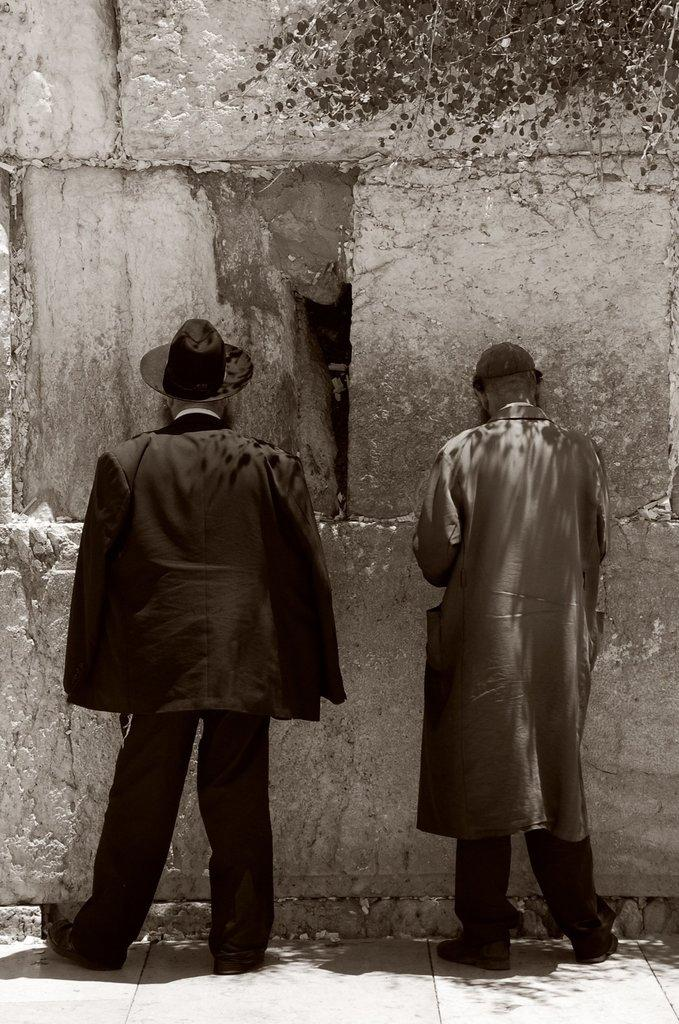How many people are in the image? There are a few people in the image. What is located on the wall in the image? There is a wall in the image, but no specific details about the wall are provided. What type of vegetation can be seen in the image? There are leaves on the top right of the image. What type of waves can be seen crashing on the shore in the image? There is no reference to waves or a shore in the image, so it is not possible to answer that question. 